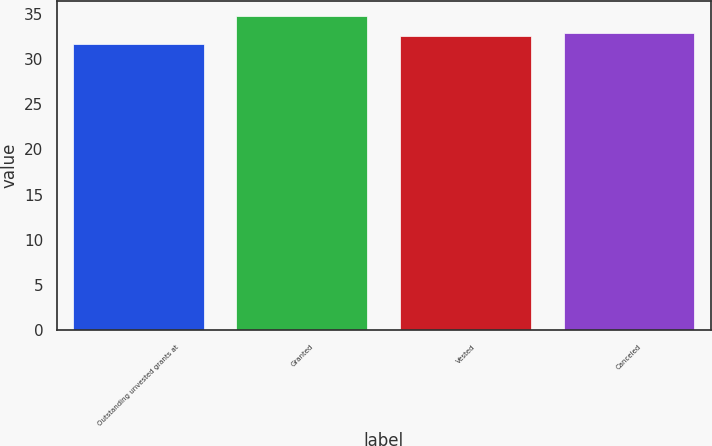Convert chart to OTSL. <chart><loc_0><loc_0><loc_500><loc_500><bar_chart><fcel>Outstanding unvested grants at<fcel>Granted<fcel>Vested<fcel>Canceled<nl><fcel>31.64<fcel>34.69<fcel>32.47<fcel>32.9<nl></chart> 